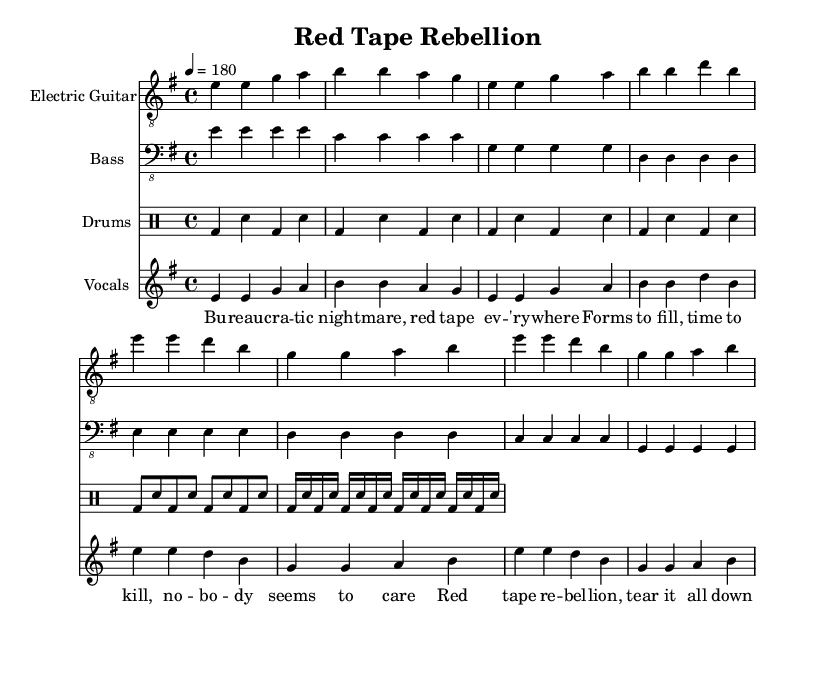What is the key signature of this music? The key signature is E minor, indicated at the beginning of the staff where there is one sharp (F#).
Answer: E minor What is the time signature of this music? The time signature is shown at the beginning of the score with a '4/4' marking, indicating four beats per measure.
Answer: 4/4 What is the tempo marking for this piece? The tempo marking is noted as '4 = 180', which means there are 180 beats per minute.
Answer: 180 What instruments are included in the score? The instruments are listed at the start of each staff: Electric Guitar, Bass, Drums, and Vocals.
Answer: Electric Guitar, Bass, Drums, Vocals How many measures are there in the chorus section? The chorus is made up of four measures, each measure containing four beats based on the structure shown in the sheet music.
Answer: 4 What lyrical theme is prominent in this punk song? The lyrics focus on themes of bureaucracy, frustration with red tape, and a rebellious desire to dismantle these obstacles.
Answer: Bureaucracy and rebellion How is the energy conveyed in the drum part? The drum part uses a consistent bass drum pattern combined with snare hits, creating a driving rhythm typical of punk music which emphasizes energy and urgency.
Answer: Driving rhythm 